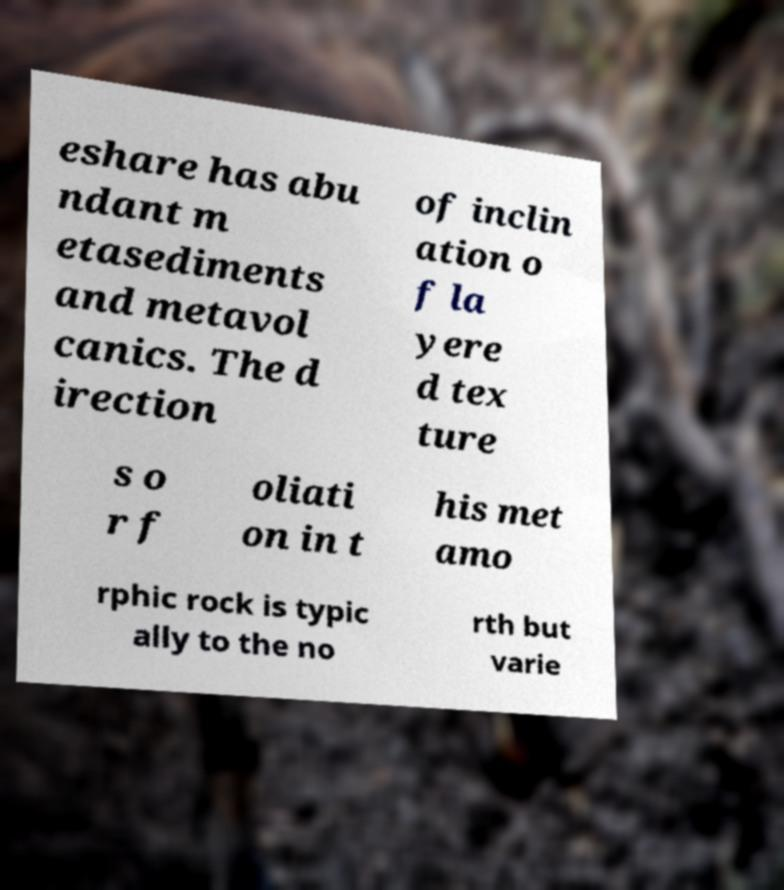Could you assist in decoding the text presented in this image and type it out clearly? eshare has abu ndant m etasediments and metavol canics. The d irection of inclin ation o f la yere d tex ture s o r f oliati on in t his met amo rphic rock is typic ally to the no rth but varie 